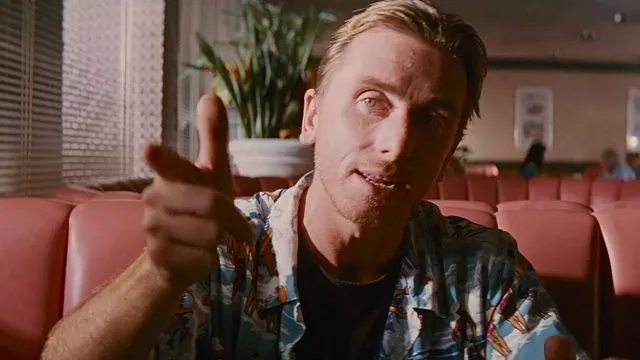Can you describe the main features of this image for me? This image features a man seated in a diner booth, presenting a casual yet focused demeanor. He's dressed in a colorful Hawaiian shirt, predominantly blue, which contrasts vividly against the dull hues of the diner's decor. His right hand gestures towards the camera, adding a dynamic touch to his relaxed pose, while his left hand rests on the table. His hair is neatly styled back, enhancing his clean, orderly appearance. The background, though softly blurred, features elements typical of a diner setting, such as other booths and a decorative plant, contributing to the authentic atmosphere of the scene. 